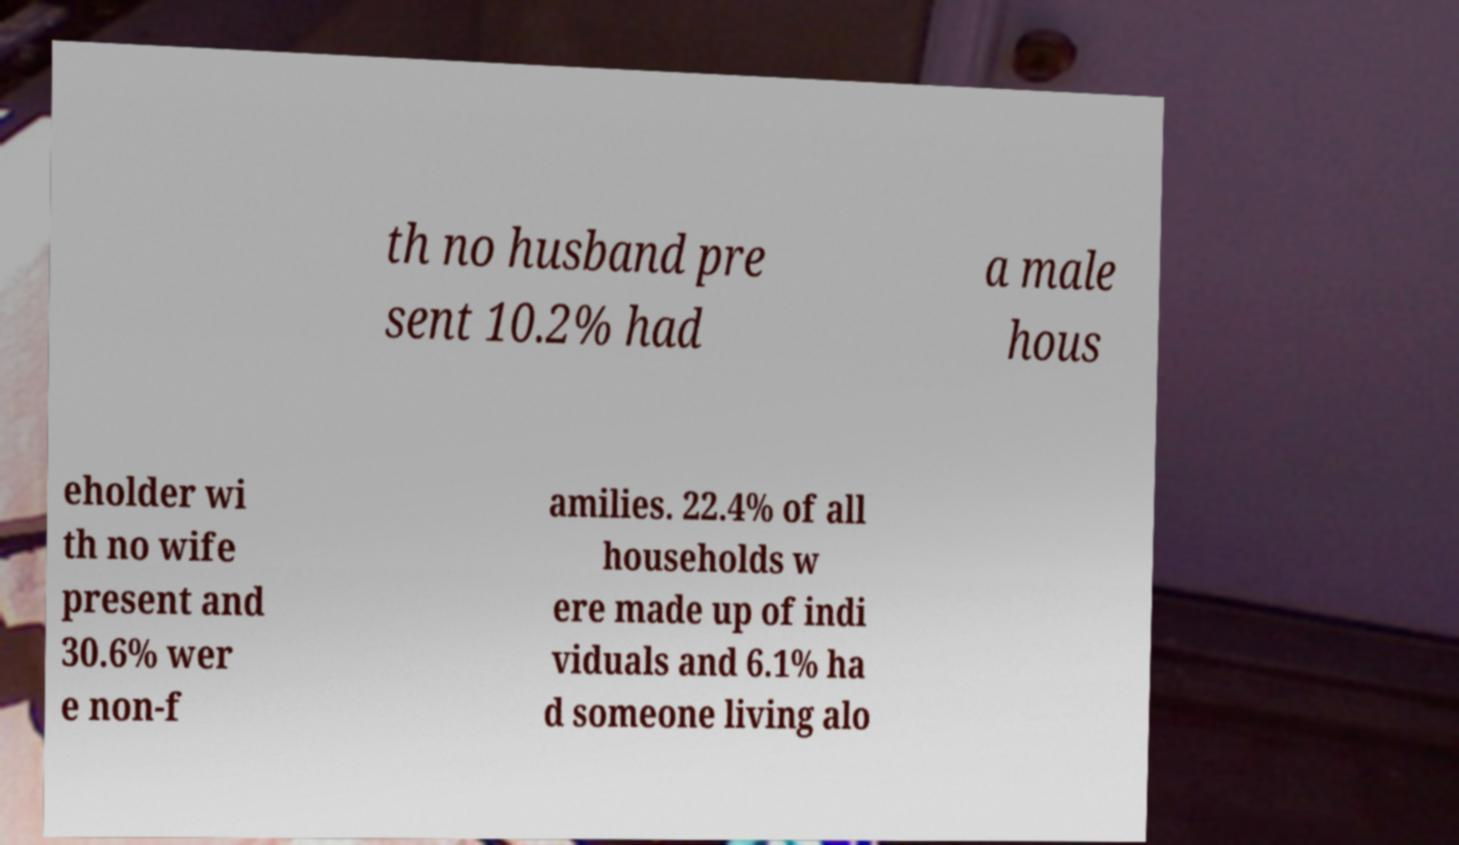Could you assist in decoding the text presented in this image and type it out clearly? th no husband pre sent 10.2% had a male hous eholder wi th no wife present and 30.6% wer e non-f amilies. 22.4% of all households w ere made up of indi viduals and 6.1% ha d someone living alo 